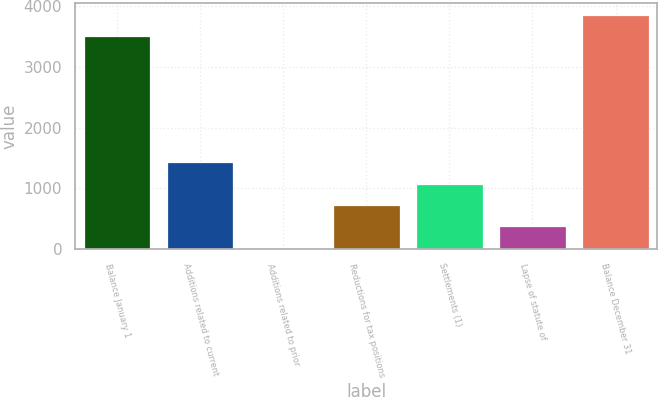Convert chart to OTSL. <chart><loc_0><loc_0><loc_500><loc_500><bar_chart><fcel>Balance January 1<fcel>Additions related to current<fcel>Additions related to prior<fcel>Reductions for tax positions<fcel>Settlements (1)<fcel>Lapse of statute of<fcel>Balance December 31<nl><fcel>3503<fcel>1427.4<fcel>23<fcel>725.2<fcel>1076.3<fcel>374.1<fcel>3854.1<nl></chart> 